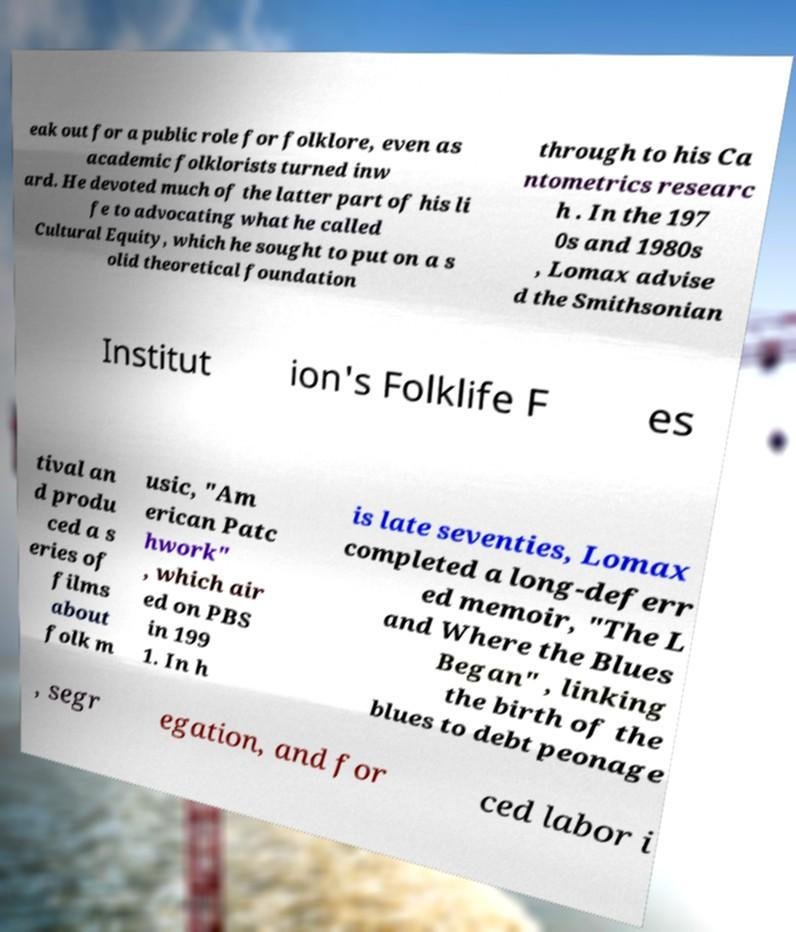Can you accurately transcribe the text from the provided image for me? eak out for a public role for folklore, even as academic folklorists turned inw ard. He devoted much of the latter part of his li fe to advocating what he called Cultural Equity, which he sought to put on a s olid theoretical foundation through to his Ca ntometrics researc h . In the 197 0s and 1980s , Lomax advise d the Smithsonian Institut ion's Folklife F es tival an d produ ced a s eries of films about folk m usic, "Am erican Patc hwork" , which air ed on PBS in 199 1. In h is late seventies, Lomax completed a long-deferr ed memoir, "The L and Where the Blues Began" , linking the birth of the blues to debt peonage , segr egation, and for ced labor i 